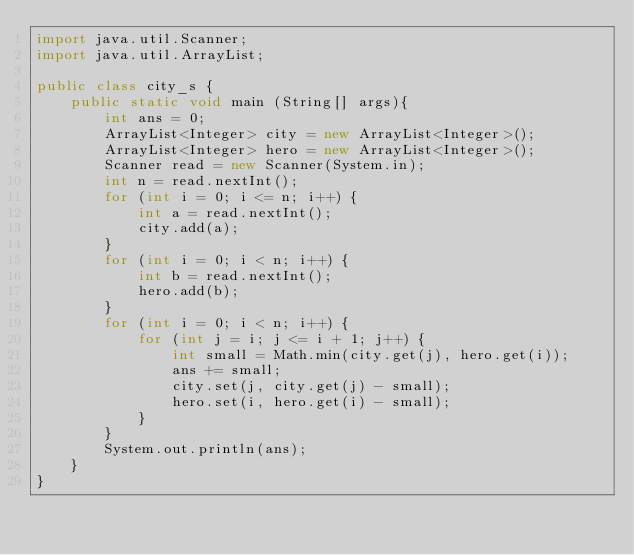<code> <loc_0><loc_0><loc_500><loc_500><_Java_>import java.util.Scanner;
import java.util.ArrayList;

public class city_s {
	public static void main (String[] args){
		int ans = 0;
        ArrayList<Integer> city = new ArrayList<Integer>();
        ArrayList<Integer> hero = new ArrayList<Integer>();
        Scanner read = new Scanner(System.in);
        int n = read.nextInt();
        for (int i = 0; i <= n; i++) {
        	int a = read.nextInt();
        	city.add(a);
        }
        for (int i = 0; i < n; i++) {
        	int b = read.nextInt();
        	hero.add(b);
        }
        for (int i = 0; i < n; i++) {
        	for (int j = i; j <= i + 1; j++) {
	        	int small = Math.min(city.get(j), hero.get(i));
	        	ans += small;
	        	city.set(j, city.get(j) - small);
	        	hero.set(i, hero.get(i) - small);
        	}
        }
        System.out.println(ans);
	}
}
</code> 